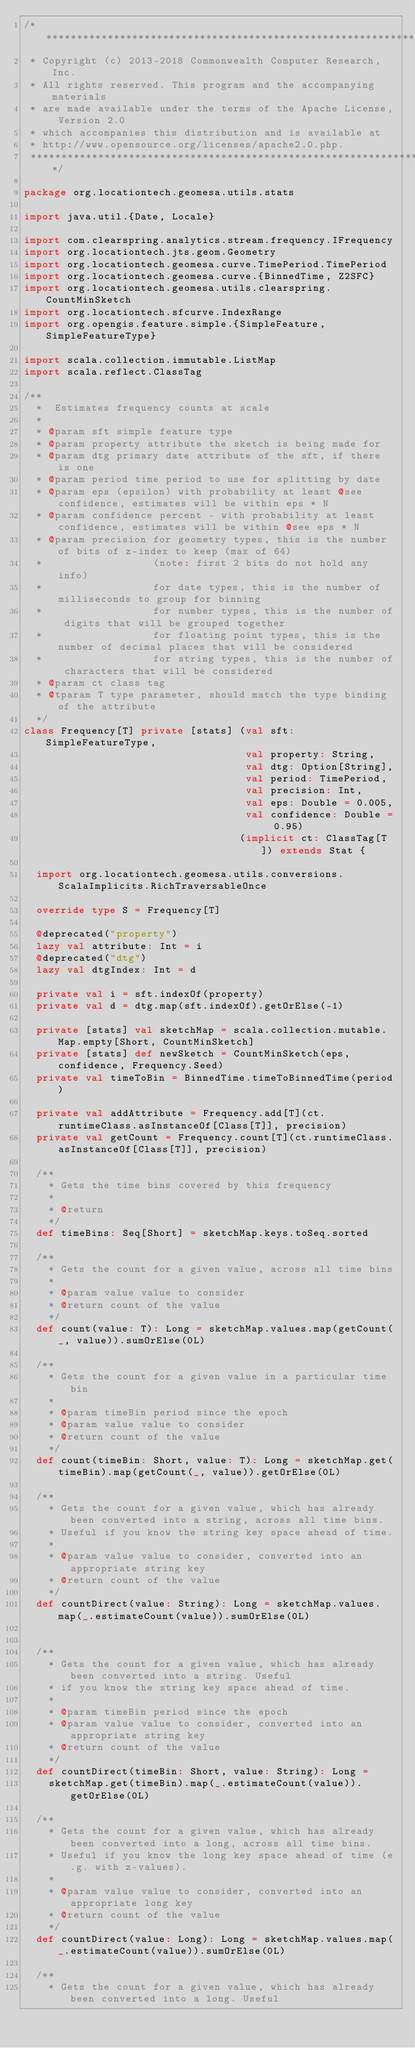Convert code to text. <code><loc_0><loc_0><loc_500><loc_500><_Scala_>/***********************************************************************
 * Copyright (c) 2013-2018 Commonwealth Computer Research, Inc.
 * All rights reserved. This program and the accompanying materials
 * are made available under the terms of the Apache License, Version 2.0
 * which accompanies this distribution and is available at
 * http://www.opensource.org/licenses/apache2.0.php.
 ***********************************************************************/

package org.locationtech.geomesa.utils.stats

import java.util.{Date, Locale}

import com.clearspring.analytics.stream.frequency.IFrequency
import org.locationtech.jts.geom.Geometry
import org.locationtech.geomesa.curve.TimePeriod.TimePeriod
import org.locationtech.geomesa.curve.{BinnedTime, Z2SFC}
import org.locationtech.geomesa.utils.clearspring.CountMinSketch
import org.locationtech.sfcurve.IndexRange
import org.opengis.feature.simple.{SimpleFeature, SimpleFeatureType}

import scala.collection.immutable.ListMap
import scala.reflect.ClassTag

/**
  *  Estimates frequency counts at scale
  *
  * @param sft simple feature type
  * @param property attribute the sketch is being made for
  * @param dtg primary date attribute of the sft, if there is one
  * @param period time period to use for splitting by date
  * @param eps (epsilon) with probability at least @see confidence, estimates will be within eps * N
  * @param confidence percent - with probability at least confidence, estimates will be within @see eps * N
  * @param precision for geometry types, this is the number of bits of z-index to keep (max of 64)
  *                  (note: first 2 bits do not hold any info)
  *                  for date types, this is the number of milliseconds to group for binning
  *                  for number types, this is the number of digits that will be grouped together
  *                  for floating point types, this is the number of decimal places that will be considered
  *                  for string types, this is the number of characters that will be considered
  * @param ct class tag
  * @tparam T type parameter, should match the type binding of the attribute
  */
class Frequency[T] private [stats] (val sft: SimpleFeatureType,
                                    val property: String,
                                    val dtg: Option[String],
                                    val period: TimePeriod,
                                    val precision: Int,
                                    val eps: Double = 0.005,
                                    val confidence: Double = 0.95)
                                   (implicit ct: ClassTag[T]) extends Stat {

  import org.locationtech.geomesa.utils.conversions.ScalaImplicits.RichTraversableOnce

  override type S = Frequency[T]

  @deprecated("property")
  lazy val attribute: Int = i
  @deprecated("dtg")
  lazy val dtgIndex: Int = d

  private val i = sft.indexOf(property)
  private val d = dtg.map(sft.indexOf).getOrElse(-1)

  private [stats] val sketchMap = scala.collection.mutable.Map.empty[Short, CountMinSketch]
  private [stats] def newSketch = CountMinSketch(eps, confidence, Frequency.Seed)
  private val timeToBin = BinnedTime.timeToBinnedTime(period)

  private val addAttribute = Frequency.add[T](ct.runtimeClass.asInstanceOf[Class[T]], precision)
  private val getCount = Frequency.count[T](ct.runtimeClass.asInstanceOf[Class[T]], precision)

  /**
    * Gets the time bins covered by this frequency
    *
    * @return
    */
  def timeBins: Seq[Short] = sketchMap.keys.toSeq.sorted

  /**
    * Gets the count for a given value, across all time bins
    *
    * @param value value to consider
    * @return count of the value
    */
  def count(value: T): Long = sketchMap.values.map(getCount(_, value)).sumOrElse(0L)

  /**
    * Gets the count for a given value in a particular time bin
    *
    * @param timeBin period since the epoch
    * @param value value to consider
    * @return count of the value
    */
  def count(timeBin: Short, value: T): Long = sketchMap.get(timeBin).map(getCount(_, value)).getOrElse(0L)

  /**
    * Gets the count for a given value, which has already been converted into a string, across all time bins.
    * Useful if you know the string key space ahead of time.
    *
    * @param value value to consider, converted into an appropriate string key
    * @return count of the value
    */
  def countDirect(value: String): Long = sketchMap.values.map(_.estimateCount(value)).sumOrElse(0L)


  /**
    * Gets the count for a given value, which has already been converted into a string. Useful
    * if you know the string key space ahead of time.
    *
    * @param timeBin period since the epoch
    * @param value value to consider, converted into an appropriate string key
    * @return count of the value
    */
  def countDirect(timeBin: Short, value: String): Long =
    sketchMap.get(timeBin).map(_.estimateCount(value)).getOrElse(0L)

  /**
    * Gets the count for a given value, which has already been converted into a long, across all time bins.
    * Useful if you know the long key space ahead of time (e.g. with z-values).
    *
    * @param value value to consider, converted into an appropriate long key
    * @return count of the value
    */
  def countDirect(value: Long): Long = sketchMap.values.map(_.estimateCount(value)).sumOrElse(0L)

  /**
    * Gets the count for a given value, which has already been converted into a long. Useful</code> 